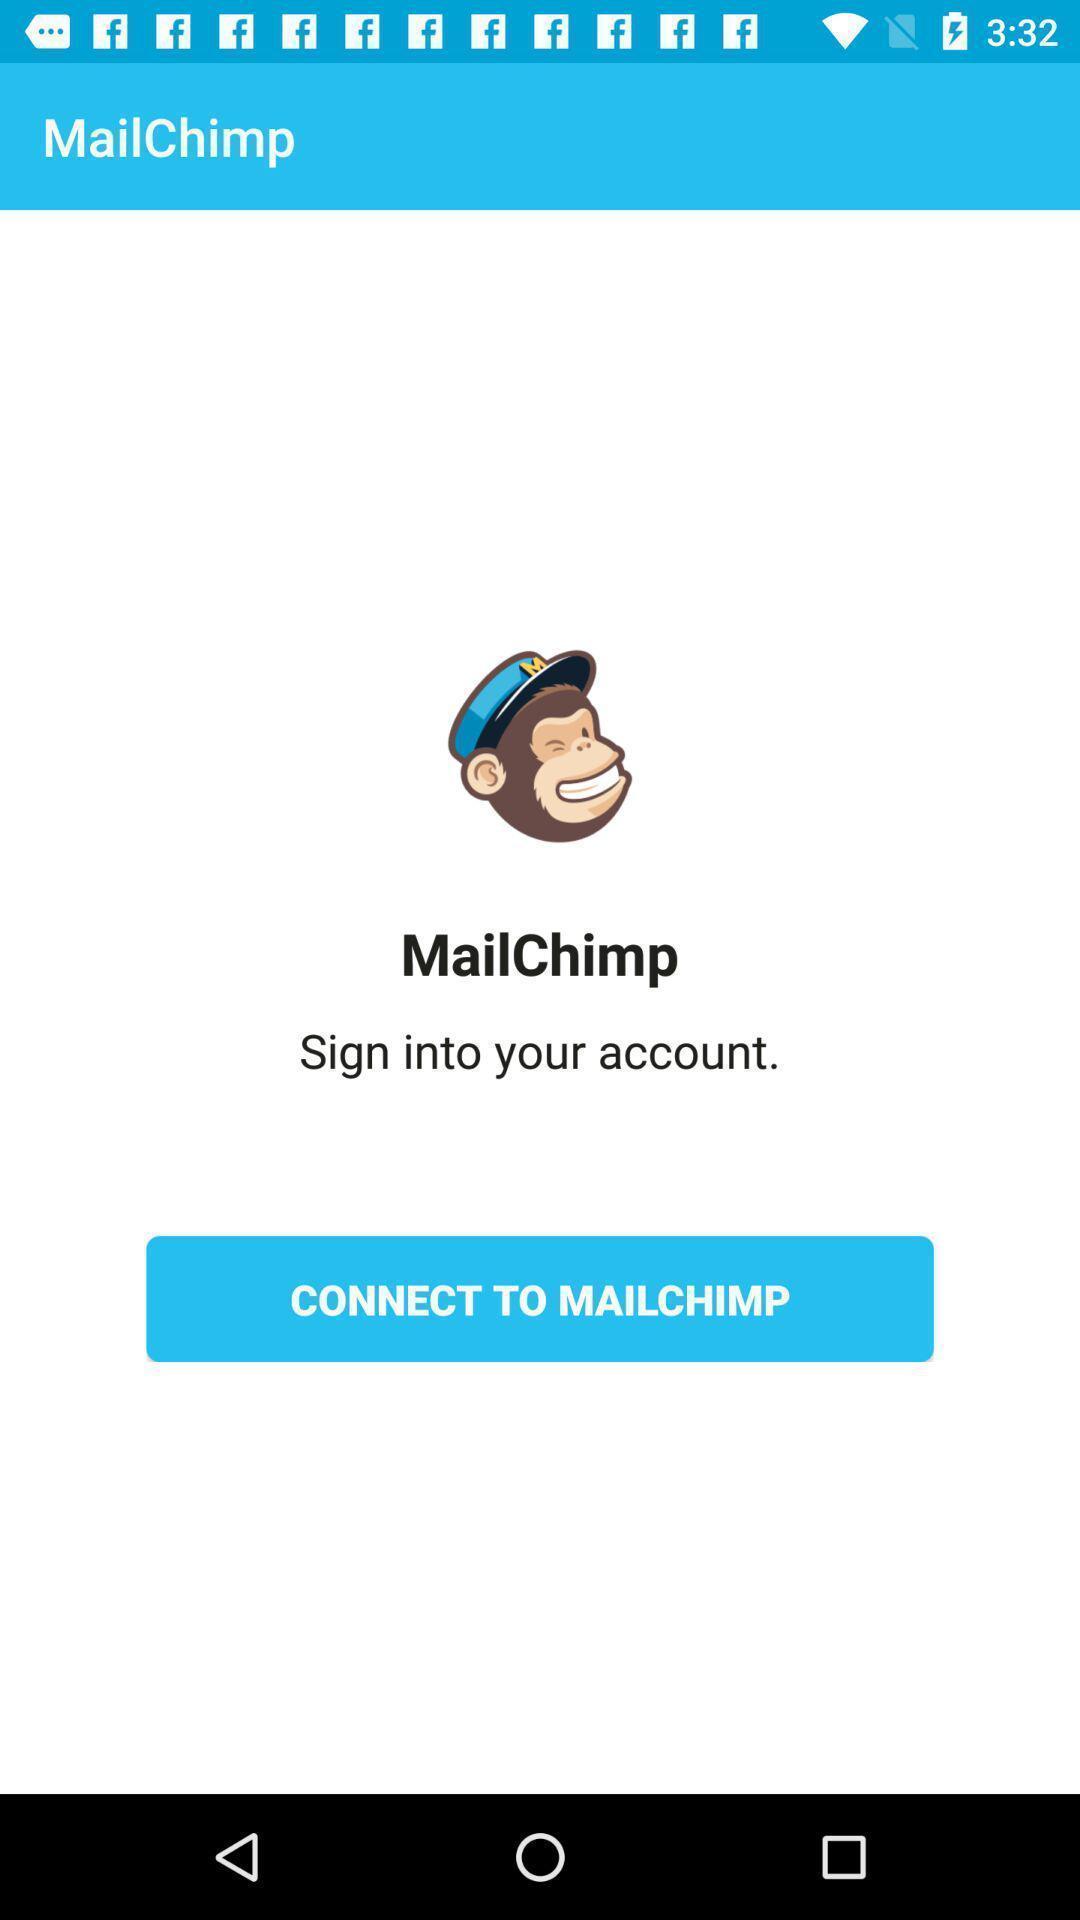Describe this image in words. Sign in page of an e-commerce app. 